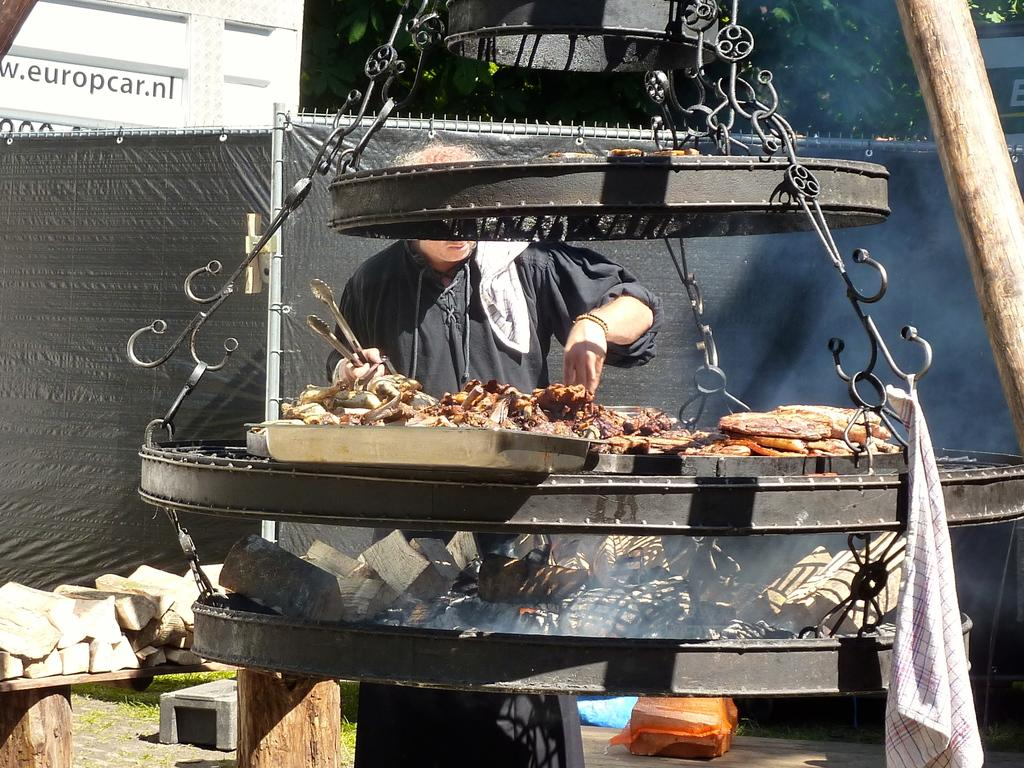<image>
Share a concise interpretation of the image provided. A man prepares meats in front of a building advertising europcar.nl 